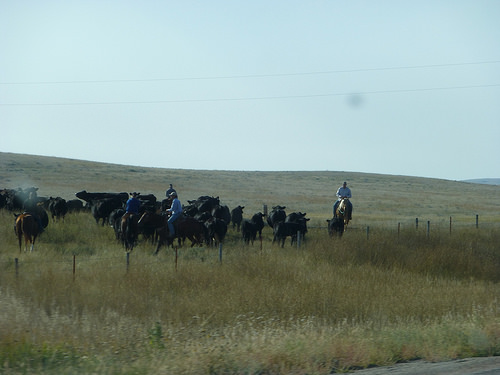<image>
Is there a horse under the man? Yes. The horse is positioned underneath the man, with the man above it in the vertical space. 